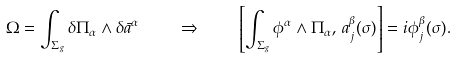Convert formula to latex. <formula><loc_0><loc_0><loc_500><loc_500>\Omega = \int _ { \Sigma _ { g } } \delta \Pi _ { \alpha } \wedge \delta \bar { a } ^ { \alpha } \quad \Rightarrow \quad \left [ \int _ { \Sigma _ { g } } \phi ^ { \alpha } \wedge \Pi _ { \alpha } , \, a _ { j } ^ { \beta } ( \sigma ) \right ] = i \phi _ { j } ^ { \beta } ( \sigma ) .</formula> 